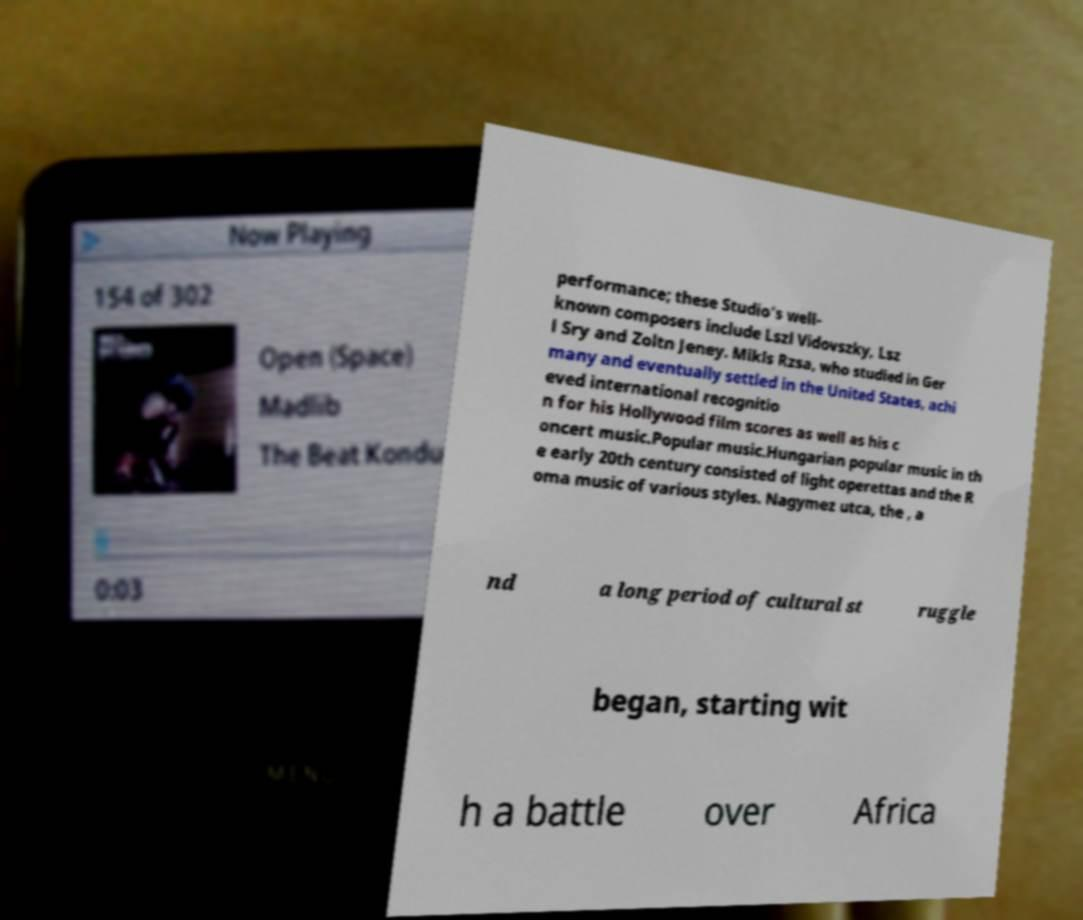Can you read and provide the text displayed in the image?This photo seems to have some interesting text. Can you extract and type it out for me? performance; these Studio's well- known composers include Lszl Vidovszky, Lsz l Sry and Zoltn Jeney. Mikls Rzsa, who studied in Ger many and eventually settled in the United States, achi eved international recognitio n for his Hollywood film scores as well as his c oncert music.Popular music.Hungarian popular music in th e early 20th century consisted of light operettas and the R oma music of various styles. Nagymez utca, the , a nd a long period of cultural st ruggle began, starting wit h a battle over Africa 